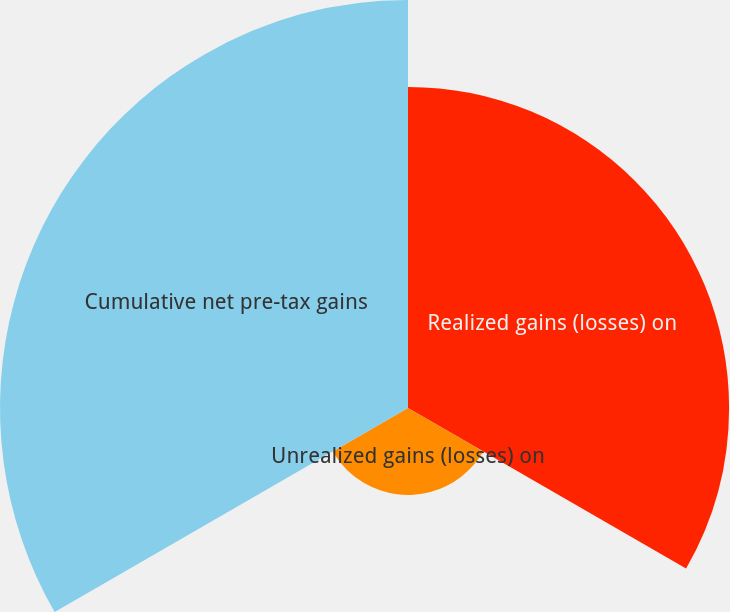Convert chart to OTSL. <chart><loc_0><loc_0><loc_500><loc_500><pie_chart><fcel>Realized gains (losses) on<fcel>Unrealized gains (losses) on<fcel>Cumulative net pre-tax gains<nl><fcel>39.35%<fcel>10.65%<fcel>50.0%<nl></chart> 